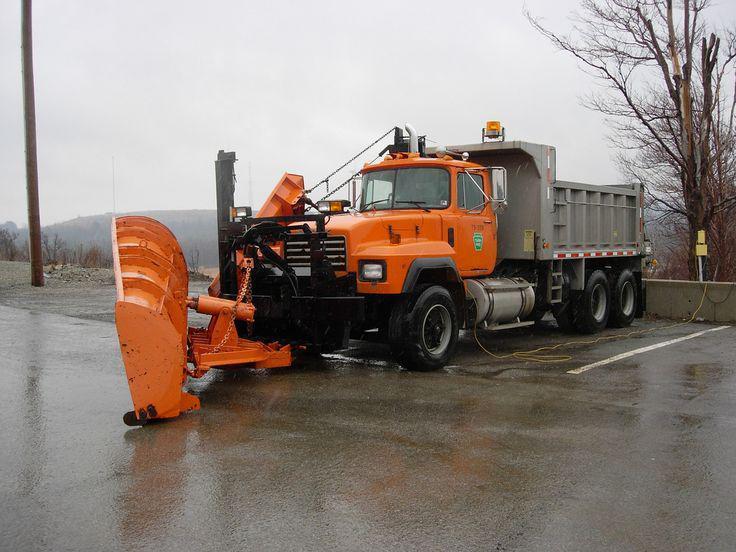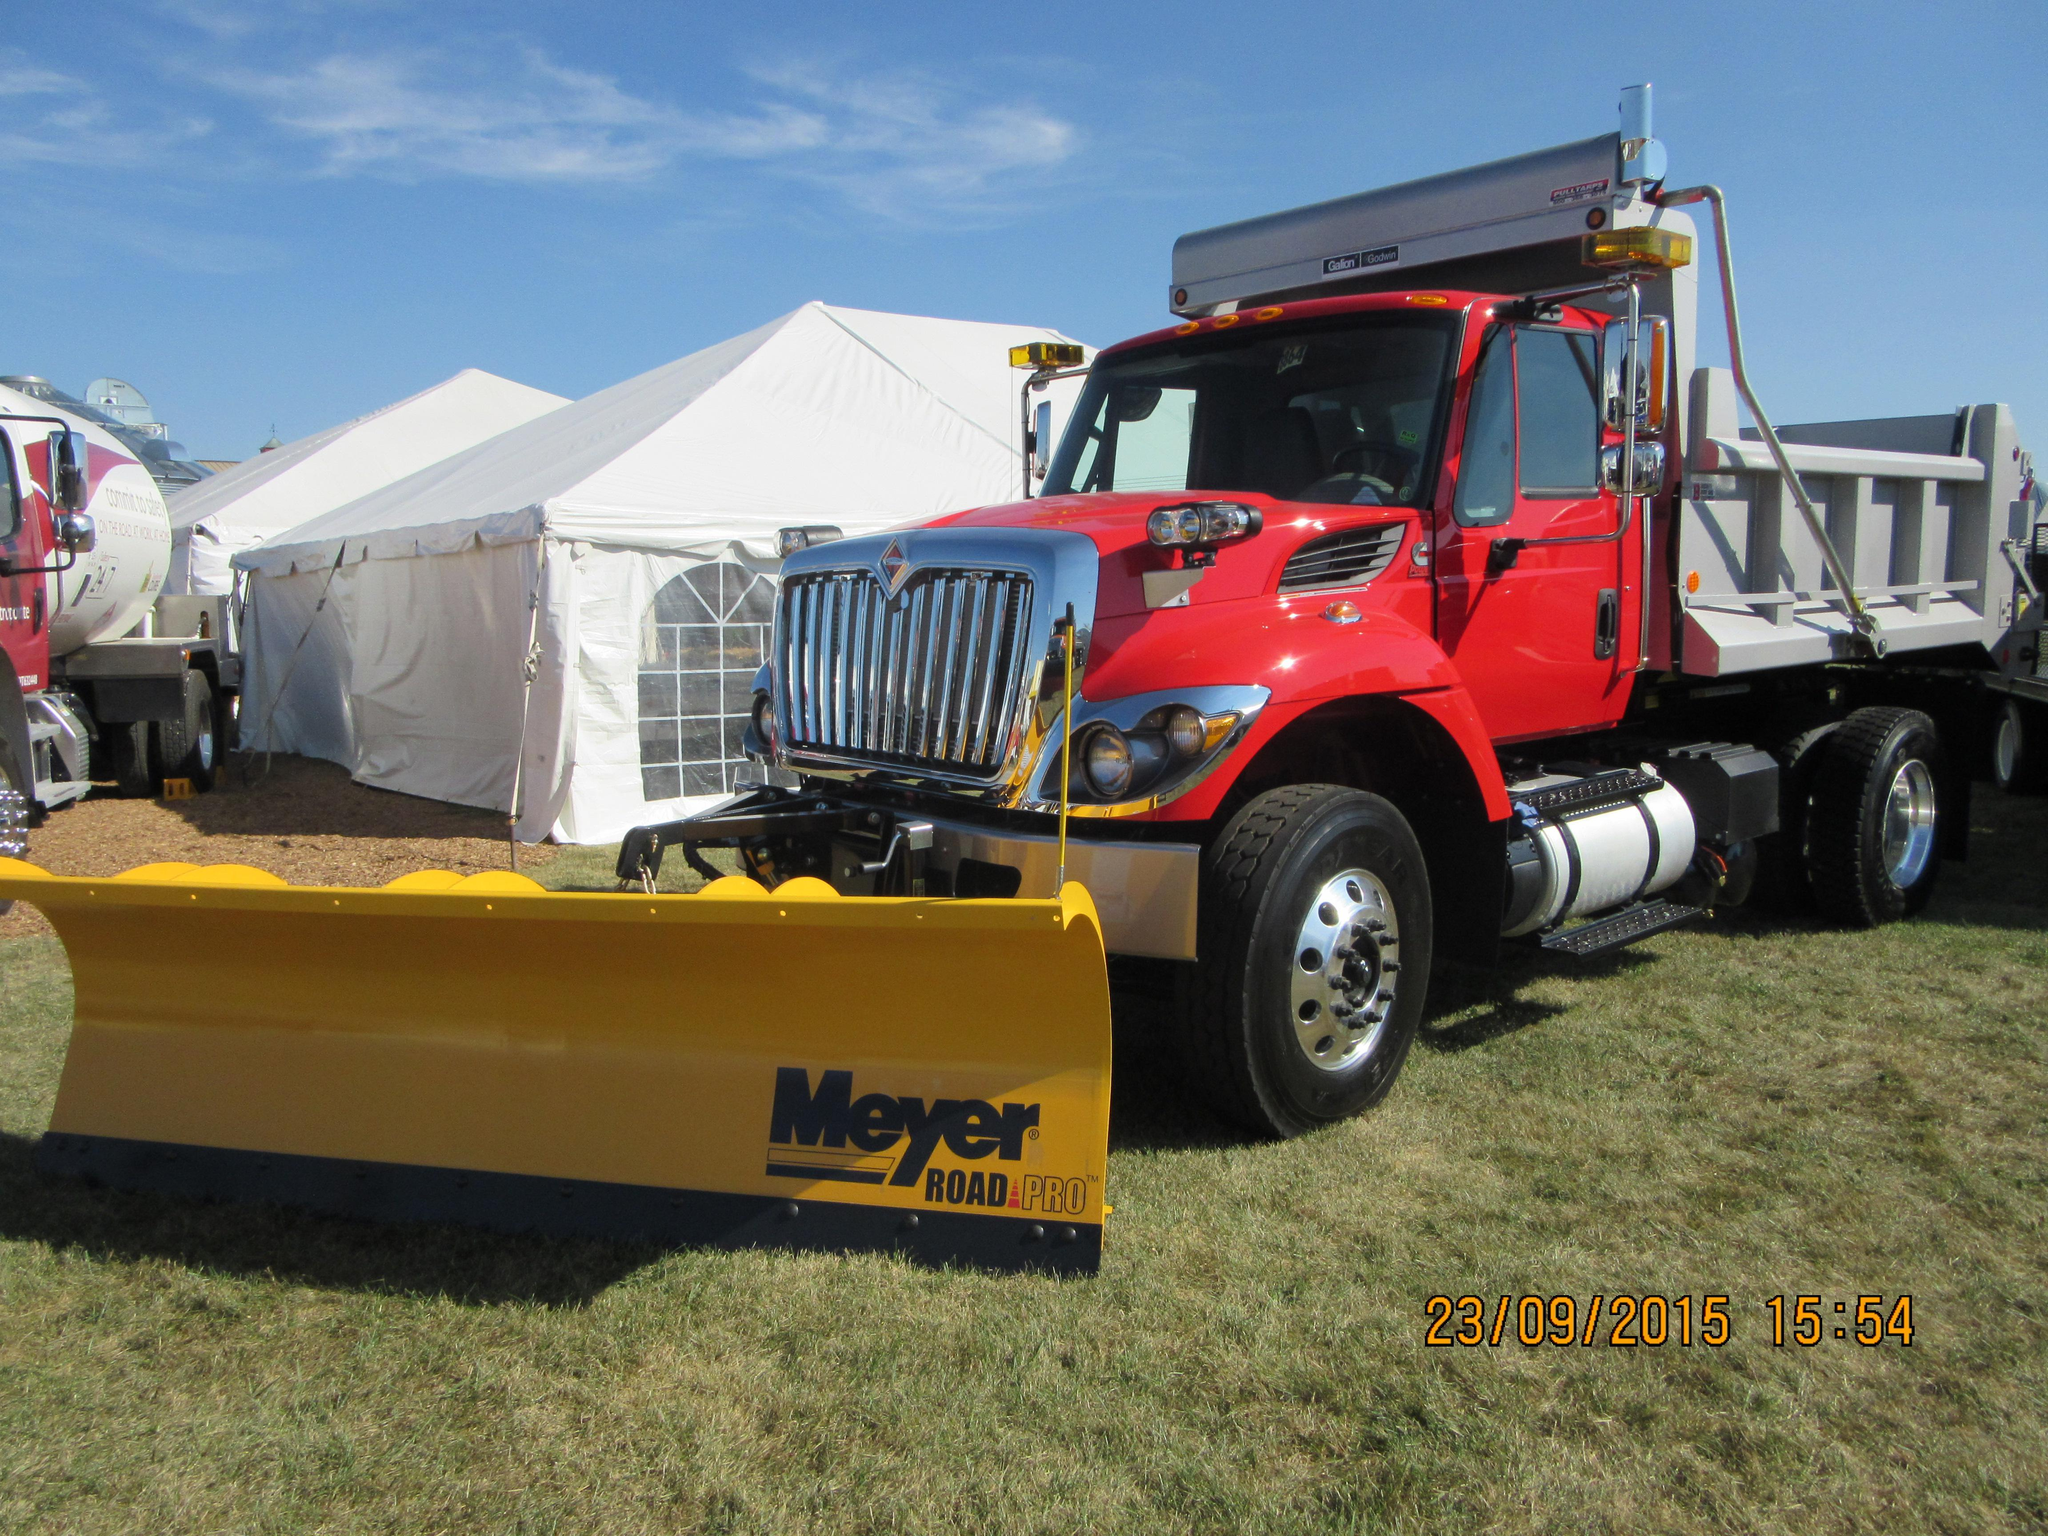The first image is the image on the left, the second image is the image on the right. Evaluate the accuracy of this statement regarding the images: "An image shows a leftward-facing truck with a bright yellow plow.". Is it true? Answer yes or no. Yes. 